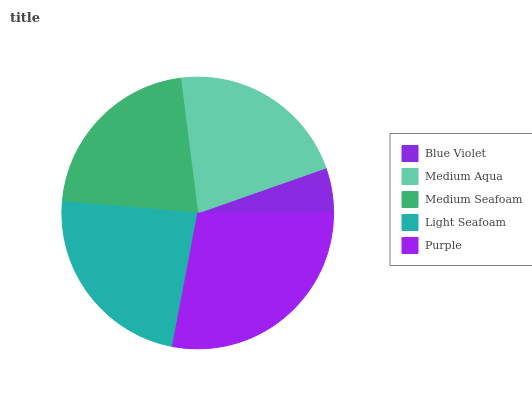Is Blue Violet the minimum?
Answer yes or no. Yes. Is Purple the maximum?
Answer yes or no. Yes. Is Medium Aqua the minimum?
Answer yes or no. No. Is Medium Aqua the maximum?
Answer yes or no. No. Is Medium Aqua greater than Blue Violet?
Answer yes or no. Yes. Is Blue Violet less than Medium Aqua?
Answer yes or no. Yes. Is Blue Violet greater than Medium Aqua?
Answer yes or no. No. Is Medium Aqua less than Blue Violet?
Answer yes or no. No. Is Medium Seafoam the high median?
Answer yes or no. Yes. Is Medium Seafoam the low median?
Answer yes or no. Yes. Is Blue Violet the high median?
Answer yes or no. No. Is Purple the low median?
Answer yes or no. No. 